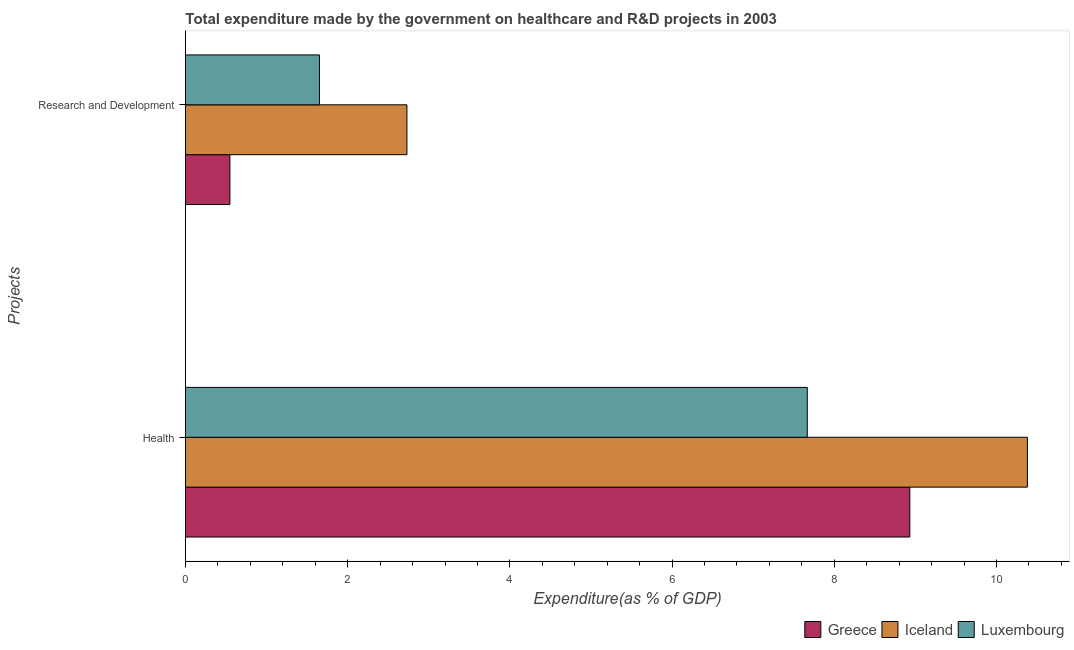How many groups of bars are there?
Your answer should be compact. 2. Are the number of bars per tick equal to the number of legend labels?
Provide a short and direct response. Yes. Are the number of bars on each tick of the Y-axis equal?
Provide a succinct answer. Yes. How many bars are there on the 1st tick from the top?
Give a very brief answer. 3. What is the label of the 1st group of bars from the top?
Your response must be concise. Research and Development. What is the expenditure in r&d in Iceland?
Your answer should be compact. 2.73. Across all countries, what is the maximum expenditure in healthcare?
Your response must be concise. 10.38. Across all countries, what is the minimum expenditure in r&d?
Provide a succinct answer. 0.55. What is the total expenditure in healthcare in the graph?
Your answer should be very brief. 26.98. What is the difference between the expenditure in healthcare in Luxembourg and that in Greece?
Ensure brevity in your answer.  -1.26. What is the difference between the expenditure in r&d in Iceland and the expenditure in healthcare in Greece?
Provide a short and direct response. -6.2. What is the average expenditure in healthcare per country?
Your answer should be compact. 8.99. What is the difference between the expenditure in healthcare and expenditure in r&d in Iceland?
Make the answer very short. 7.65. What is the ratio of the expenditure in healthcare in Luxembourg to that in Iceland?
Make the answer very short. 0.74. Is the expenditure in healthcare in Luxembourg less than that in Greece?
Ensure brevity in your answer.  Yes. Are all the bars in the graph horizontal?
Keep it short and to the point. Yes. How many countries are there in the graph?
Ensure brevity in your answer.  3. What is the difference between two consecutive major ticks on the X-axis?
Ensure brevity in your answer.  2. Are the values on the major ticks of X-axis written in scientific E-notation?
Make the answer very short. No. Does the graph contain grids?
Make the answer very short. No. How many legend labels are there?
Give a very brief answer. 3. How are the legend labels stacked?
Ensure brevity in your answer.  Horizontal. What is the title of the graph?
Give a very brief answer. Total expenditure made by the government on healthcare and R&D projects in 2003. What is the label or title of the X-axis?
Your answer should be very brief. Expenditure(as % of GDP). What is the label or title of the Y-axis?
Your answer should be very brief. Projects. What is the Expenditure(as % of GDP) in Greece in Health?
Provide a short and direct response. 8.93. What is the Expenditure(as % of GDP) of Iceland in Health?
Your answer should be very brief. 10.38. What is the Expenditure(as % of GDP) in Luxembourg in Health?
Make the answer very short. 7.67. What is the Expenditure(as % of GDP) of Greece in Research and Development?
Offer a very short reply. 0.55. What is the Expenditure(as % of GDP) of Iceland in Research and Development?
Provide a short and direct response. 2.73. What is the Expenditure(as % of GDP) in Luxembourg in Research and Development?
Make the answer very short. 1.65. Across all Projects, what is the maximum Expenditure(as % of GDP) in Greece?
Make the answer very short. 8.93. Across all Projects, what is the maximum Expenditure(as % of GDP) in Iceland?
Make the answer very short. 10.38. Across all Projects, what is the maximum Expenditure(as % of GDP) of Luxembourg?
Keep it short and to the point. 7.67. Across all Projects, what is the minimum Expenditure(as % of GDP) of Greece?
Make the answer very short. 0.55. Across all Projects, what is the minimum Expenditure(as % of GDP) in Iceland?
Offer a very short reply. 2.73. Across all Projects, what is the minimum Expenditure(as % of GDP) in Luxembourg?
Provide a succinct answer. 1.65. What is the total Expenditure(as % of GDP) of Greece in the graph?
Provide a succinct answer. 9.48. What is the total Expenditure(as % of GDP) in Iceland in the graph?
Keep it short and to the point. 13.11. What is the total Expenditure(as % of GDP) of Luxembourg in the graph?
Provide a succinct answer. 9.32. What is the difference between the Expenditure(as % of GDP) in Greece in Health and that in Research and Development?
Your answer should be very brief. 8.38. What is the difference between the Expenditure(as % of GDP) in Iceland in Health and that in Research and Development?
Provide a short and direct response. 7.65. What is the difference between the Expenditure(as % of GDP) in Luxembourg in Health and that in Research and Development?
Keep it short and to the point. 6.02. What is the difference between the Expenditure(as % of GDP) in Greece in Health and the Expenditure(as % of GDP) in Iceland in Research and Development?
Offer a very short reply. 6.2. What is the difference between the Expenditure(as % of GDP) of Greece in Health and the Expenditure(as % of GDP) of Luxembourg in Research and Development?
Your answer should be very brief. 7.28. What is the difference between the Expenditure(as % of GDP) in Iceland in Health and the Expenditure(as % of GDP) in Luxembourg in Research and Development?
Give a very brief answer. 8.73. What is the average Expenditure(as % of GDP) in Greece per Projects?
Make the answer very short. 4.74. What is the average Expenditure(as % of GDP) of Iceland per Projects?
Give a very brief answer. 6.56. What is the average Expenditure(as % of GDP) of Luxembourg per Projects?
Offer a terse response. 4.66. What is the difference between the Expenditure(as % of GDP) in Greece and Expenditure(as % of GDP) in Iceland in Health?
Your answer should be very brief. -1.45. What is the difference between the Expenditure(as % of GDP) of Greece and Expenditure(as % of GDP) of Luxembourg in Health?
Your answer should be compact. 1.26. What is the difference between the Expenditure(as % of GDP) in Iceland and Expenditure(as % of GDP) in Luxembourg in Health?
Your answer should be very brief. 2.71. What is the difference between the Expenditure(as % of GDP) in Greece and Expenditure(as % of GDP) in Iceland in Research and Development?
Offer a terse response. -2.18. What is the difference between the Expenditure(as % of GDP) in Greece and Expenditure(as % of GDP) in Luxembourg in Research and Development?
Your response must be concise. -1.1. What is the difference between the Expenditure(as % of GDP) of Iceland and Expenditure(as % of GDP) of Luxembourg in Research and Development?
Ensure brevity in your answer.  1.08. What is the ratio of the Expenditure(as % of GDP) of Greece in Health to that in Research and Development?
Make the answer very short. 16.31. What is the ratio of the Expenditure(as % of GDP) of Iceland in Health to that in Research and Development?
Your response must be concise. 3.8. What is the ratio of the Expenditure(as % of GDP) in Luxembourg in Health to that in Research and Development?
Provide a succinct answer. 4.64. What is the difference between the highest and the second highest Expenditure(as % of GDP) of Greece?
Make the answer very short. 8.38. What is the difference between the highest and the second highest Expenditure(as % of GDP) of Iceland?
Ensure brevity in your answer.  7.65. What is the difference between the highest and the second highest Expenditure(as % of GDP) in Luxembourg?
Your answer should be compact. 6.02. What is the difference between the highest and the lowest Expenditure(as % of GDP) of Greece?
Your response must be concise. 8.38. What is the difference between the highest and the lowest Expenditure(as % of GDP) in Iceland?
Your answer should be compact. 7.65. What is the difference between the highest and the lowest Expenditure(as % of GDP) in Luxembourg?
Keep it short and to the point. 6.02. 